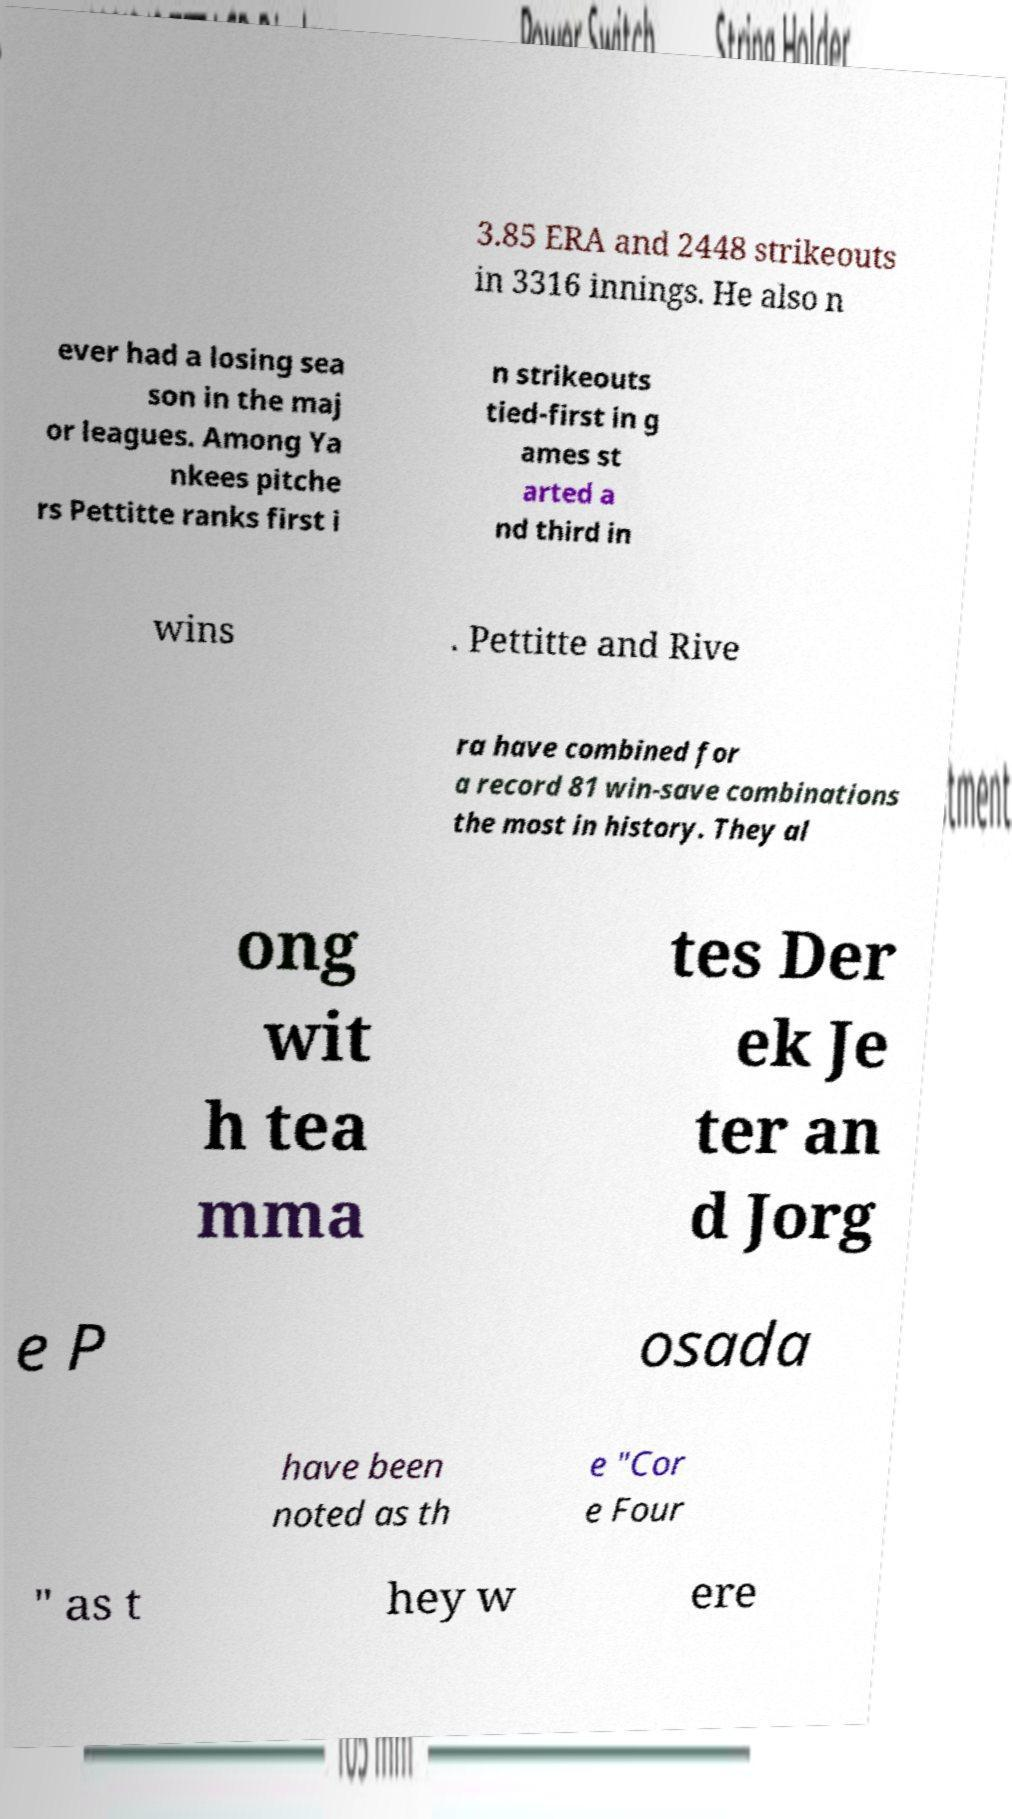Please read and relay the text visible in this image. What does it say? 3.85 ERA and 2448 strikeouts in 3316 innings. He also n ever had a losing sea son in the maj or leagues. Among Ya nkees pitche rs Pettitte ranks first i n strikeouts tied-first in g ames st arted a nd third in wins . Pettitte and Rive ra have combined for a record 81 win-save combinations the most in history. They al ong wit h tea mma tes Der ek Je ter an d Jorg e P osada have been noted as th e "Cor e Four " as t hey w ere 